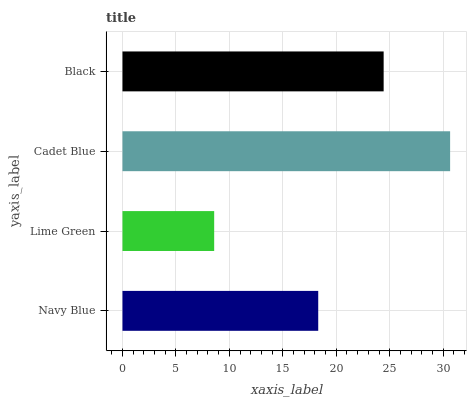Is Lime Green the minimum?
Answer yes or no. Yes. Is Cadet Blue the maximum?
Answer yes or no. Yes. Is Cadet Blue the minimum?
Answer yes or no. No. Is Lime Green the maximum?
Answer yes or no. No. Is Cadet Blue greater than Lime Green?
Answer yes or no. Yes. Is Lime Green less than Cadet Blue?
Answer yes or no. Yes. Is Lime Green greater than Cadet Blue?
Answer yes or no. No. Is Cadet Blue less than Lime Green?
Answer yes or no. No. Is Black the high median?
Answer yes or no. Yes. Is Navy Blue the low median?
Answer yes or no. Yes. Is Cadet Blue the high median?
Answer yes or no. No. Is Black the low median?
Answer yes or no. No. 